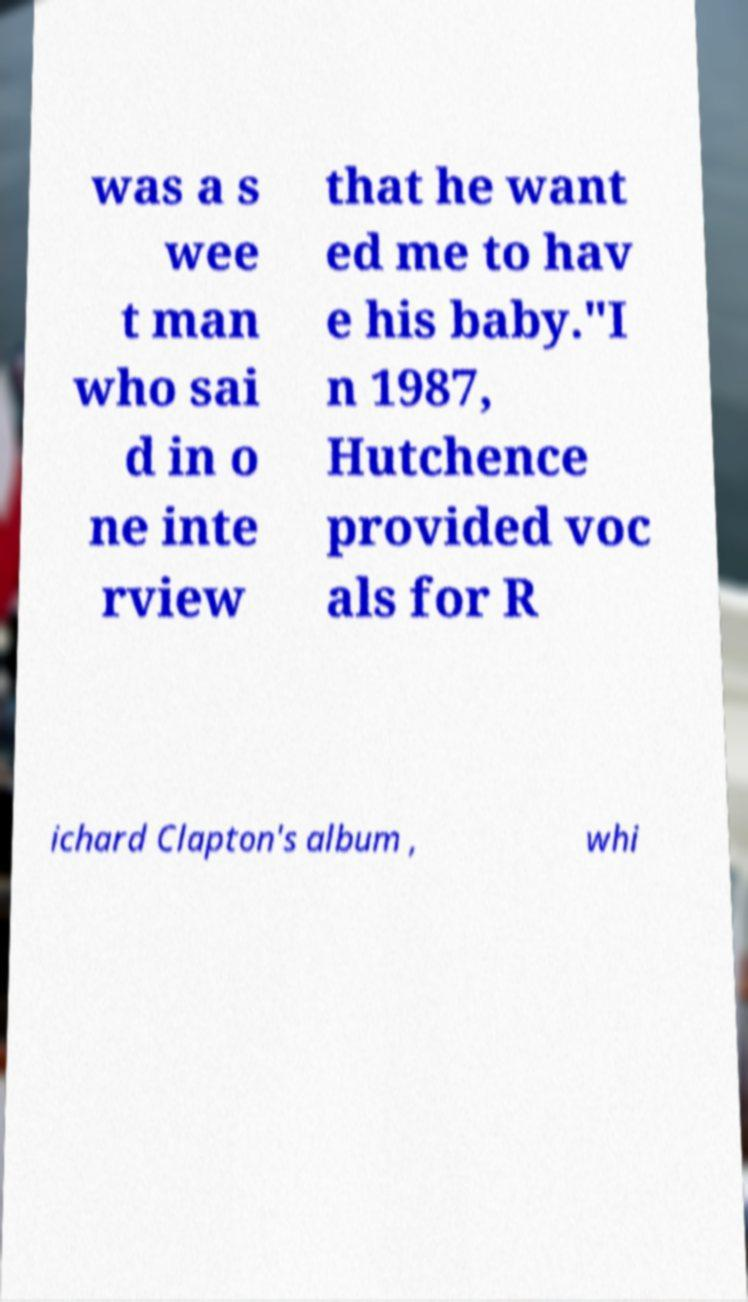Can you read and provide the text displayed in the image?This photo seems to have some interesting text. Can you extract and type it out for me? was a s wee t man who sai d in o ne inte rview that he want ed me to hav e his baby."I n 1987, Hutchence provided voc als for R ichard Clapton's album , whi 